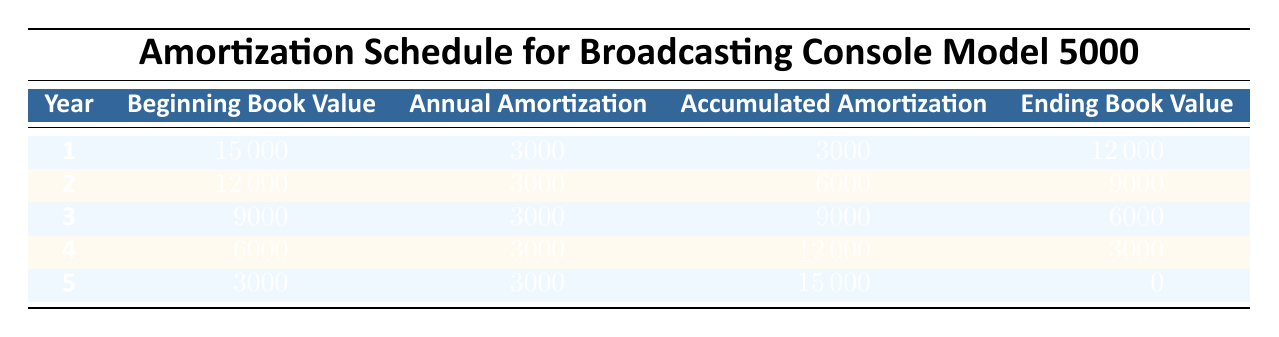What is the purchase price of the Broadcasting Console Model 5000? The purchase price is listed directly in the data as 15000.
Answer: 15000 What was the annual amortization amount for each year? The annual amortization is consistently 3000 each year, stated in the annual amortization column of the table.
Answer: 3000 What is the ending book value at the end of year 4? According to the table, the ending book value for year 4 is given directly as 3000.
Answer: 3000 What is the total accumulated amortization after 3 years? By summing the accumulated amortization for the first three years, we find 3000 (year 1) + 3000 (year 2) + 3000 (year 3) = 9000.
Answer: 9000 Did the ending book value reach zero by the end of year 5? The table shows that the ending book value for year 5 is 0, indicating that it did reach zero.
Answer: Yes What was the beginning book value for year 3? The beginning book value for year 3 is directly stated in the table as 9000.
Answer: 9000 What is the decrease in book value from the beginning of year 1 to the end of year 5? The beginning book value for year 1 is 15000 and the ending book value for year 5 is 0. The decrease is calculated as 15000 - 0 = 15000.
Answer: 15000 How much total money has been amortized over the 5 years? The total amortization is equal to the annual amortization times the number of years: 3000 * 5 = 15000. This matches the total accumulated amortization shown in year 5.
Answer: 15000 What would the accumulated amortization be in year 4? In year 4, the accumulated amortization is indicated in the table as 12000, which is calculated by adding the annual amortization up to that point.
Answer: 12000 